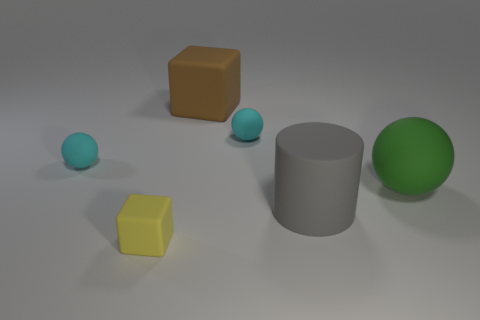Subtract all tiny rubber balls. How many balls are left? 1 Subtract all red cylinders. How many cyan spheres are left? 2 Add 3 tiny cyan matte cylinders. How many objects exist? 9 Subtract all cylinders. How many objects are left? 5 Add 2 small cyan matte objects. How many small cyan matte objects exist? 4 Subtract 1 green spheres. How many objects are left? 5 Subtract all yellow rubber blocks. Subtract all tiny rubber things. How many objects are left? 2 Add 6 brown things. How many brown things are left? 7 